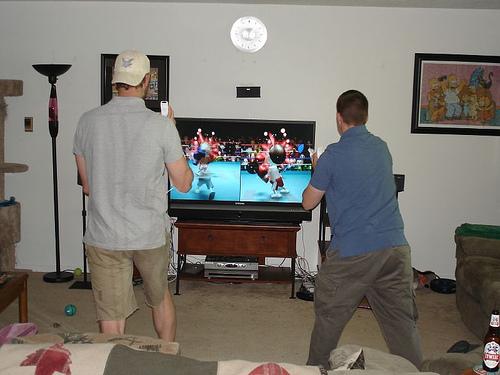What kind of floor is it?
Concise answer only. Carpet. What color is the man on left shirt?
Short answer required. Gray. Are they bowling on Wii?
Be succinct. No. What is the man on the left doing?
Short answer required. Playing. Insignia of closest hat is for what sport?
Keep it brief. Boxing. Is this a business type event?
Be succinct. No. What is the occasion?
Write a very short answer. Party. What is round and hanging on the back wall?
Be succinct. Clock. Is there a Simpson's poster on the wall?
Answer briefly. Yes. Is this a special occasion?
Keep it brief. No. Are the lights on?
Give a very brief answer. Yes. What surface are they standing on?
Concise answer only. Carpet. How many people are visible in the room?
Give a very brief answer. 2. Are these people at work?
Answer briefly. No. Is he wearing khaki shorts?
Be succinct. Yes. Could this be an appraisal?
Be succinct. No. Is the person on the left of the photograph male or female?
Keep it brief. Male. What game are they playing?
Short answer required. Boxing. Would the beer in the foreground make playing Wii Boxing more fun if consumed quickly?
Short answer required. Yes. What is everyone doing with their electronic devices?
Answer briefly. Playing video games. Why is there a glow in the room?
Be succinct. Light. Is there a chef pictured here?
Write a very short answer. No. Is the man cooking?
Write a very short answer. No. What are the people learning to do?
Concise answer only. Box. Did this man just unbox is Wii?
Concise answer only. No. Are these people playing a video game in a bar?
Be succinct. No. Are the walls made of wood?
Answer briefly. No. What letter is on the man's hat?
Quick response, please. None. 